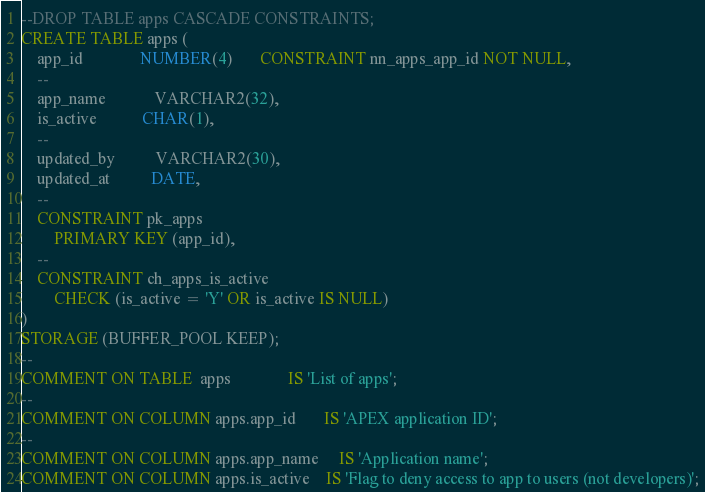Convert code to text. <code><loc_0><loc_0><loc_500><loc_500><_SQL_>--DROP TABLE apps CASCADE CONSTRAINTS;
CREATE TABLE apps (
    app_id              NUMBER(4)       CONSTRAINT nn_apps_app_id NOT NULL,
    --
    app_name            VARCHAR2(32),
    is_active           CHAR(1),
    --
    updated_by          VARCHAR2(30),
    updated_at          DATE,
    --
    CONSTRAINT pk_apps
        PRIMARY KEY (app_id),
    --
    CONSTRAINT ch_apps_is_active
        CHECK (is_active = 'Y' OR is_active IS NULL)
)
STORAGE (BUFFER_POOL KEEP);
--
COMMENT ON TABLE  apps              IS 'List of apps';
--
COMMENT ON COLUMN apps.app_id       IS 'APEX application ID';
--
COMMENT ON COLUMN apps.app_name     IS 'Application name';
COMMENT ON COLUMN apps.is_active    IS 'Flag to deny access to app to users (not developers)';

</code> 